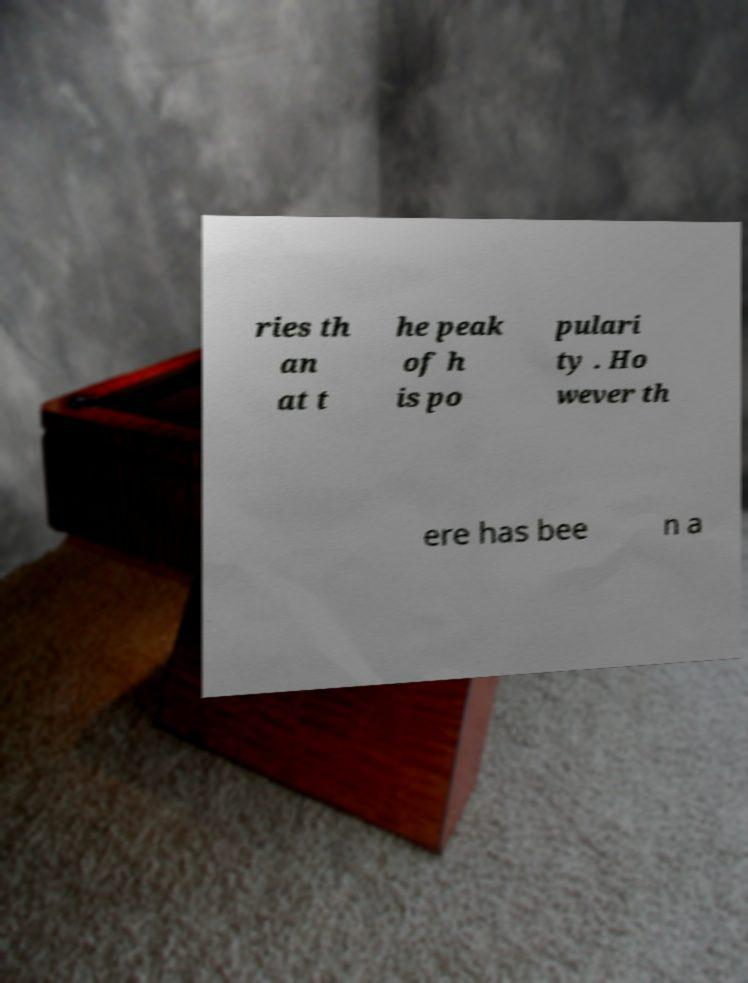For documentation purposes, I need the text within this image transcribed. Could you provide that? ries th an at t he peak of h is po pulari ty . Ho wever th ere has bee n a 